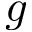Convert formula to latex. <formula><loc_0><loc_0><loc_500><loc_500>g</formula> 